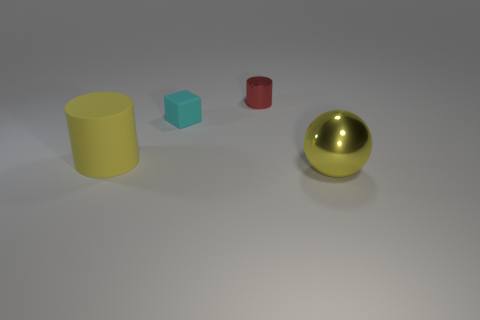Add 4 small cyan shiny objects. How many objects exist? 8 Subtract all cubes. How many objects are left? 3 Add 1 small blue rubber objects. How many small blue rubber objects exist? 1 Subtract 1 cyan cubes. How many objects are left? 3 Subtract all cylinders. Subtract all tiny gray metallic balls. How many objects are left? 2 Add 4 large balls. How many large balls are left? 5 